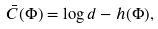Convert formula to latex. <formula><loc_0><loc_0><loc_500><loc_500>\bar { C } ( \Phi ) = \log d - h ( \Phi ) ,</formula> 